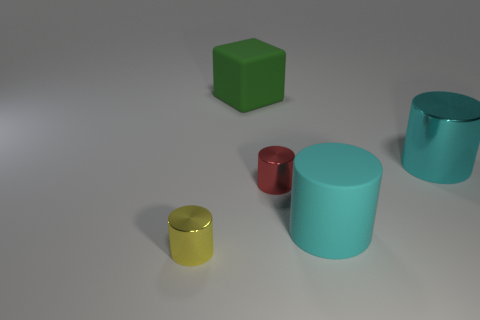What is the color of the tiny cylinder right of the small yellow cylinder?
Offer a terse response. Red. What is the material of the small object behind the big cyan cylinder that is on the left side of the big cyan metallic object?
Ensure brevity in your answer.  Metal. Is there a red rubber object that has the same size as the yellow metal cylinder?
Offer a terse response. No. What number of things are shiny objects in front of the cyan metal cylinder or green objects behind the red metal cylinder?
Your answer should be very brief. 3. Do the cyan matte thing that is behind the tiny yellow cylinder and the green thing behind the small yellow shiny object have the same size?
Offer a terse response. Yes. There is a matte object right of the matte cube; is there a yellow shiny object on the right side of it?
Offer a terse response. No. There is a large rubber cylinder; what number of shiny objects are behind it?
Your response must be concise. 2. How many other objects are there of the same color as the big metallic thing?
Offer a terse response. 1. Are there fewer large cubes that are to the right of the red cylinder than tiny red metallic cylinders that are behind the cyan matte thing?
Keep it short and to the point. Yes. How many objects are cyan objects behind the tiny red thing or tiny blue things?
Your answer should be very brief. 1. 